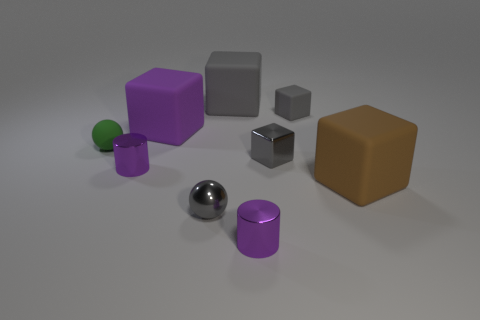Subtract all cyan cylinders. How many gray blocks are left? 3 Subtract 2 blocks. How many blocks are left? 3 Subtract all green blocks. Subtract all brown cylinders. How many blocks are left? 5 Add 1 metal cubes. How many objects exist? 10 Subtract all cylinders. How many objects are left? 7 Subtract 0 cyan cylinders. How many objects are left? 9 Subtract all tiny shiny things. Subtract all large brown rubber cubes. How many objects are left? 4 Add 5 tiny gray objects. How many tiny gray objects are left? 8 Add 7 purple blocks. How many purple blocks exist? 8 